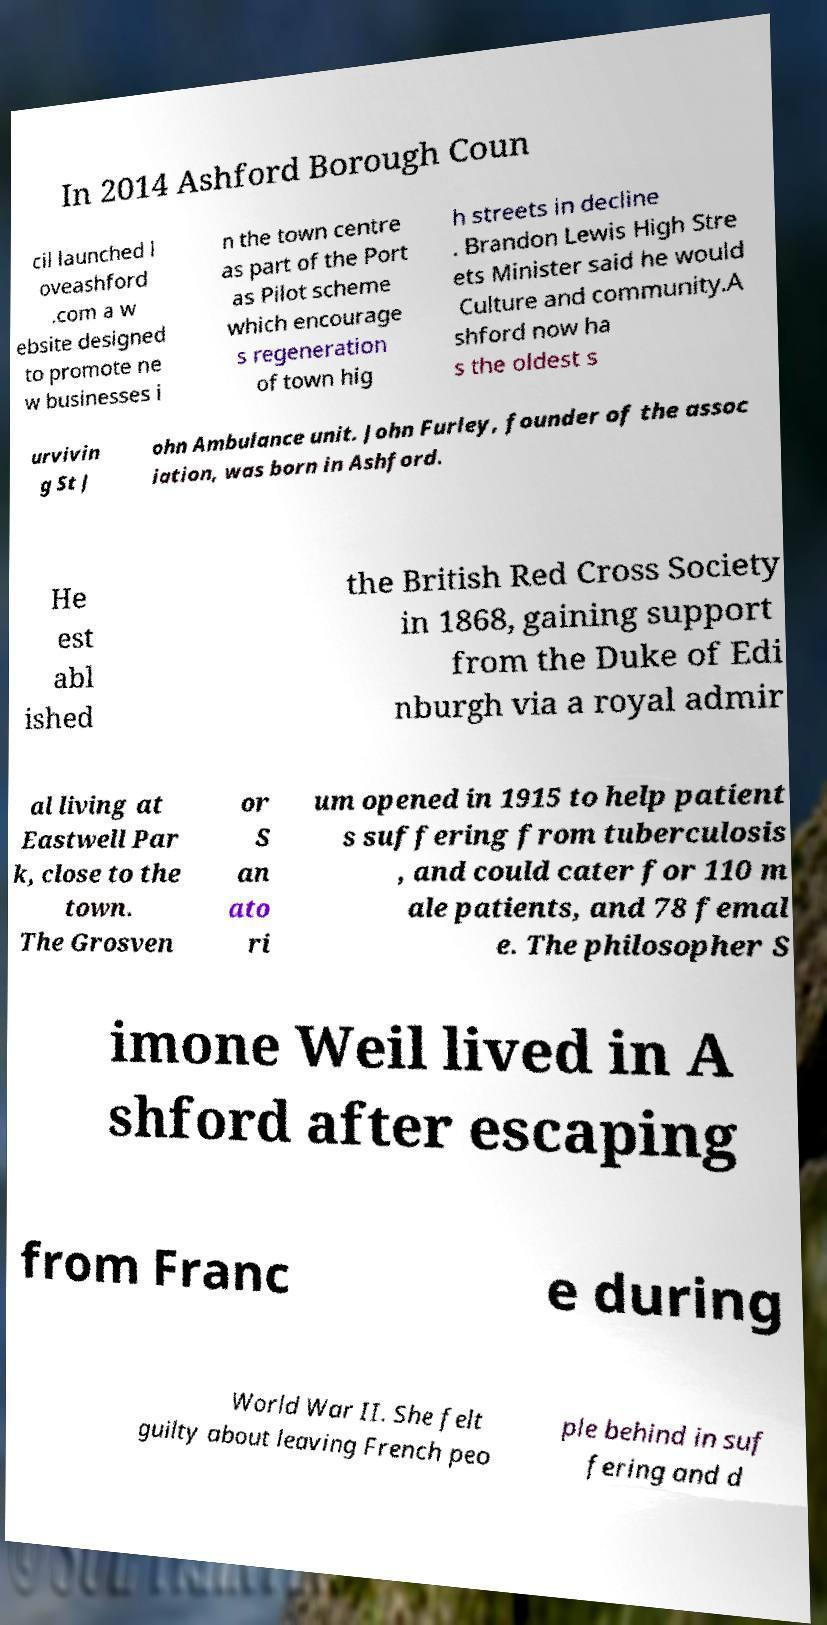What messages or text are displayed in this image? I need them in a readable, typed format. In 2014 Ashford Borough Coun cil launched l oveashford .com a w ebsite designed to promote ne w businesses i n the town centre as part of the Port as Pilot scheme which encourage s regeneration of town hig h streets in decline . Brandon Lewis High Stre ets Minister said he would Culture and community.A shford now ha s the oldest s urvivin g St J ohn Ambulance unit. John Furley, founder of the assoc iation, was born in Ashford. He est abl ished the British Red Cross Society in 1868, gaining support from the Duke of Edi nburgh via a royal admir al living at Eastwell Par k, close to the town. The Grosven or S an ato ri um opened in 1915 to help patient s suffering from tuberculosis , and could cater for 110 m ale patients, and 78 femal e. The philosopher S imone Weil lived in A shford after escaping from Franc e during World War II. She felt guilty about leaving French peo ple behind in suf fering and d 